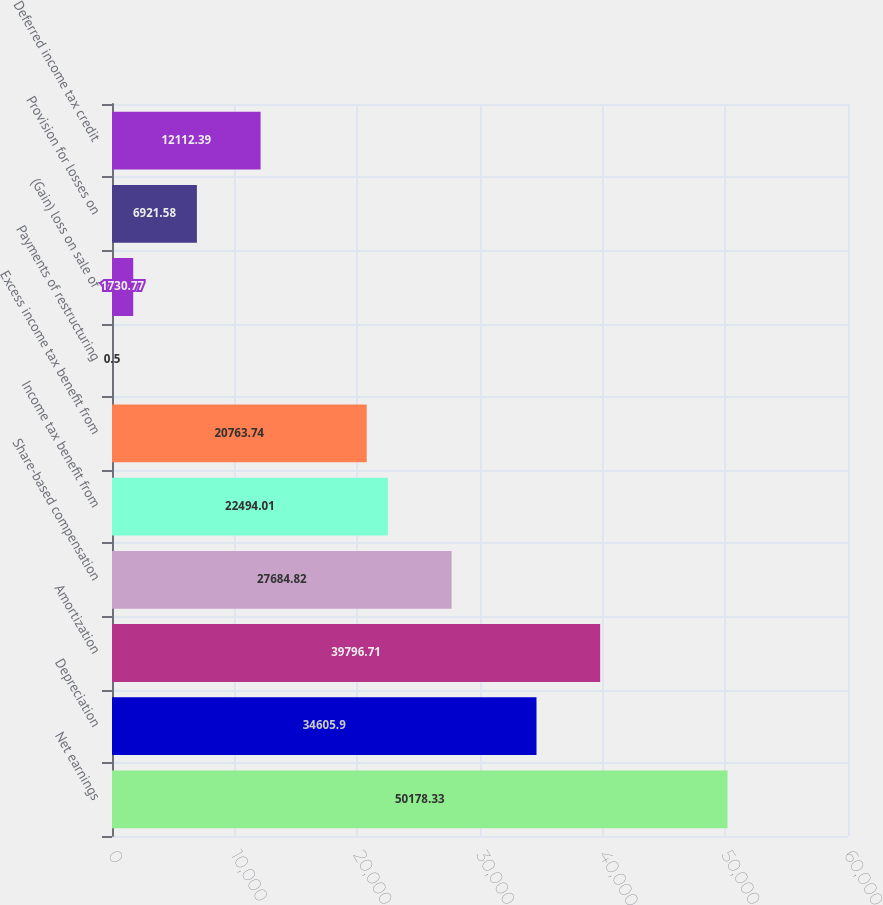Convert chart. <chart><loc_0><loc_0><loc_500><loc_500><bar_chart><fcel>Net earnings<fcel>Depreciation<fcel>Amortization<fcel>Share-based compensation<fcel>Income tax benefit from<fcel>Excess income tax benefit from<fcel>Payments of restructuring<fcel>(Gain) loss on sale of<fcel>Provision for losses on<fcel>Deferred income tax credit<nl><fcel>50178.3<fcel>34605.9<fcel>39796.7<fcel>27684.8<fcel>22494<fcel>20763.7<fcel>0.5<fcel>1730.77<fcel>6921.58<fcel>12112.4<nl></chart> 